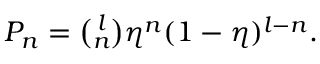<formula> <loc_0><loc_0><loc_500><loc_500>\begin{array} { r } { P _ { n } = \binom { l } { n } \eta ^ { n } ( 1 - \eta ) ^ { l - n } . } \end{array}</formula> 